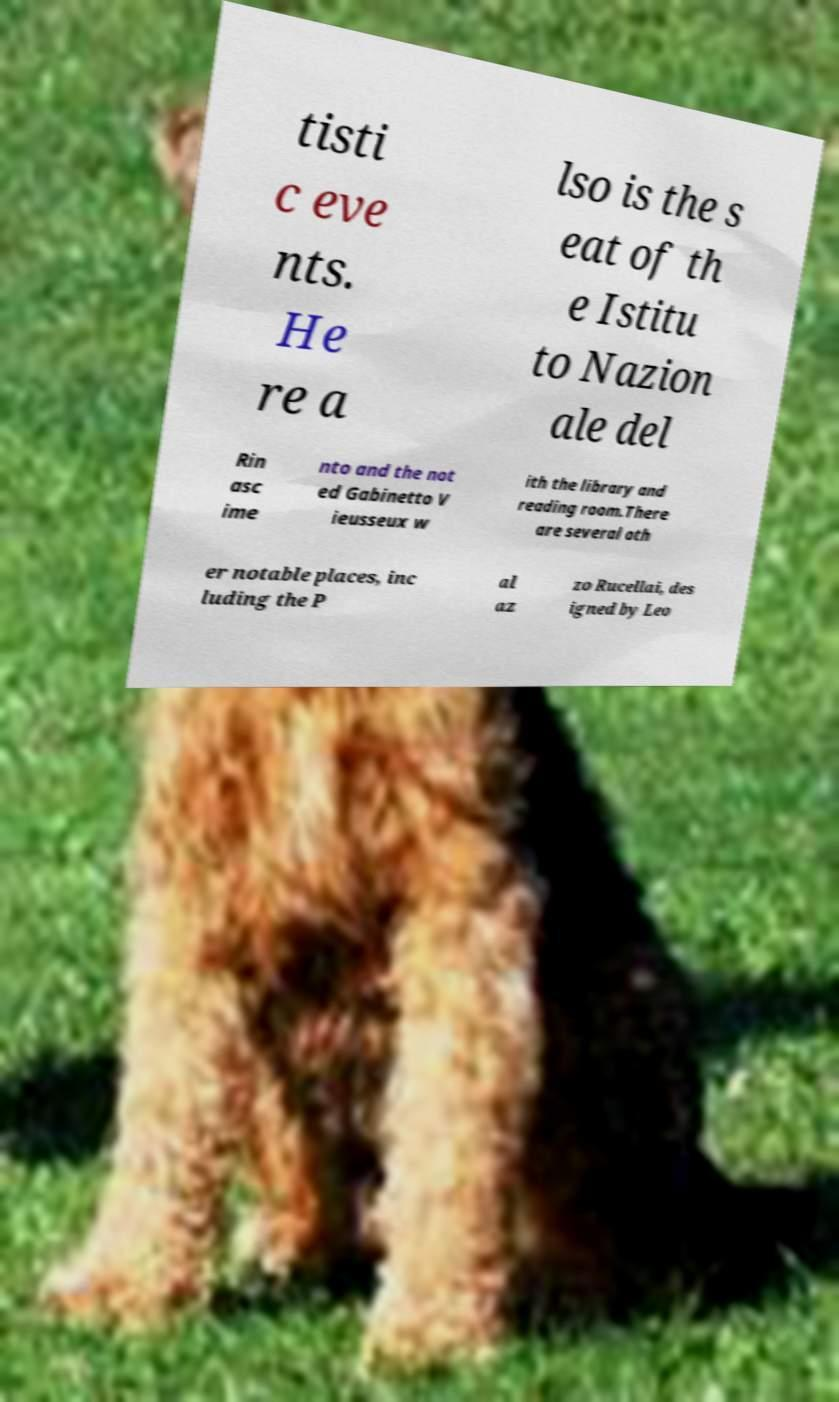Could you extract and type out the text from this image? tisti c eve nts. He re a lso is the s eat of th e Istitu to Nazion ale del Rin asc ime nto and the not ed Gabinetto V ieusseux w ith the library and reading room.There are several oth er notable places, inc luding the P al az zo Rucellai, des igned by Leo 